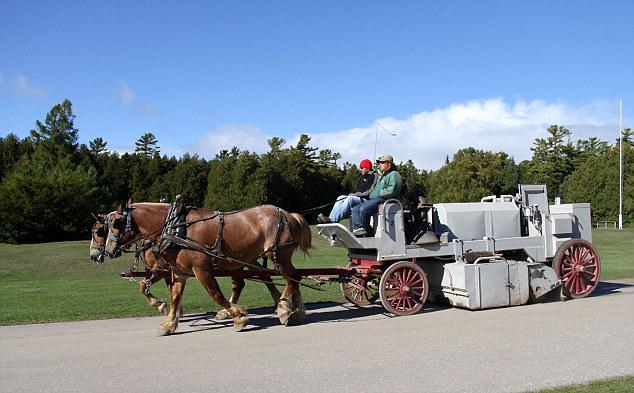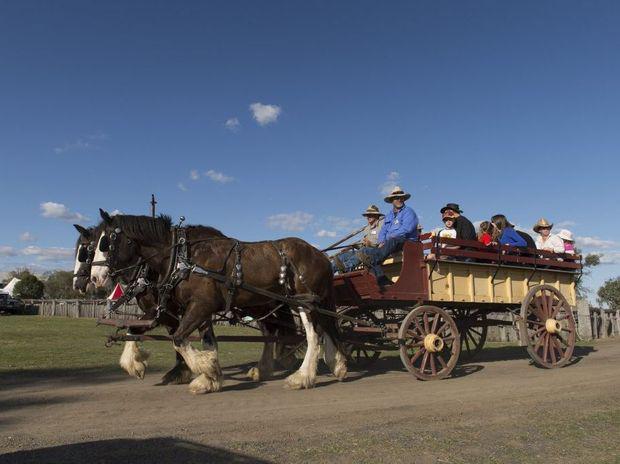The first image is the image on the left, the second image is the image on the right. Evaluate the accuracy of this statement regarding the images: "The horse-drawn cart on the right side is located in a rural setting.". Is it true? Answer yes or no. Yes. 